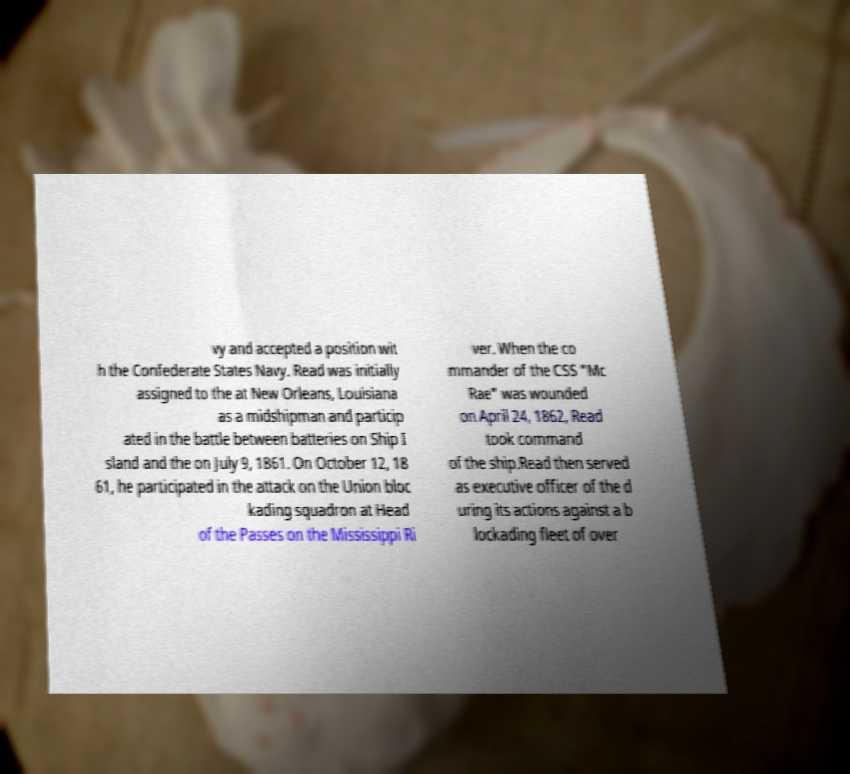Please read and relay the text visible in this image. What does it say? vy and accepted a position wit h the Confederate States Navy. Read was initially assigned to the at New Orleans, Louisiana as a midshipman and particip ated in the battle between batteries on Ship I sland and the on July 9, 1861. On October 12, 18 61, he participated in the attack on the Union bloc kading squadron at Head of the Passes on the Mississippi Ri ver. When the co mmander of the CSS "Mc Rae" was wounded on April 24, 1862, Read took command of the ship.Read then served as executive officer of the d uring its actions against a b lockading fleet of over 